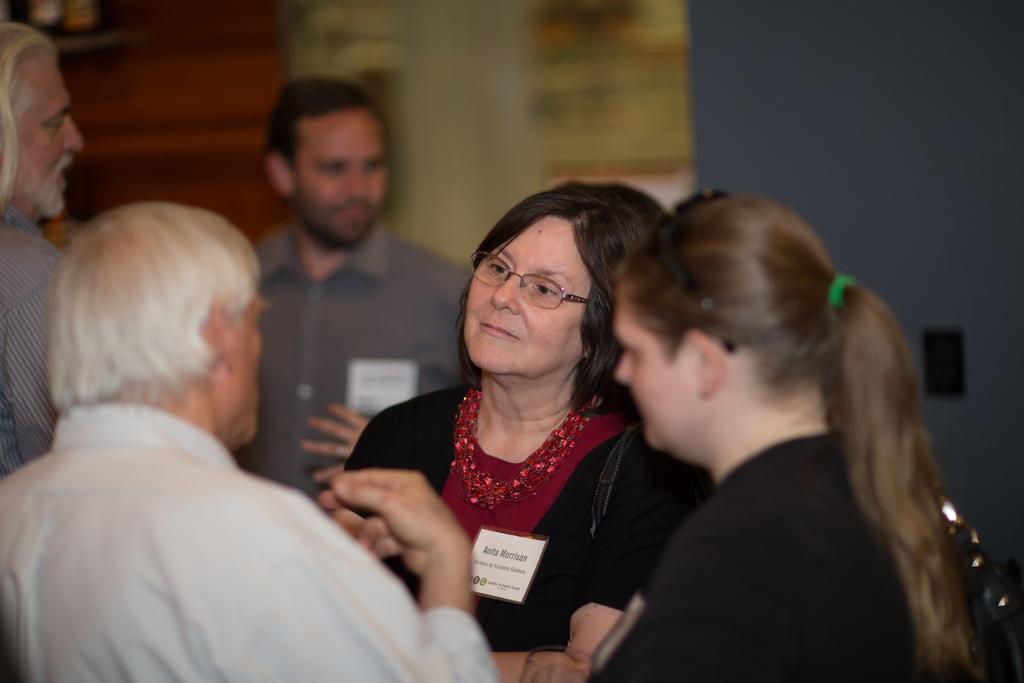Please provide a concise description of this image. In this picture we can see some people are standing, a woman in the middle is wearing spectacles, there is a blurry background. 